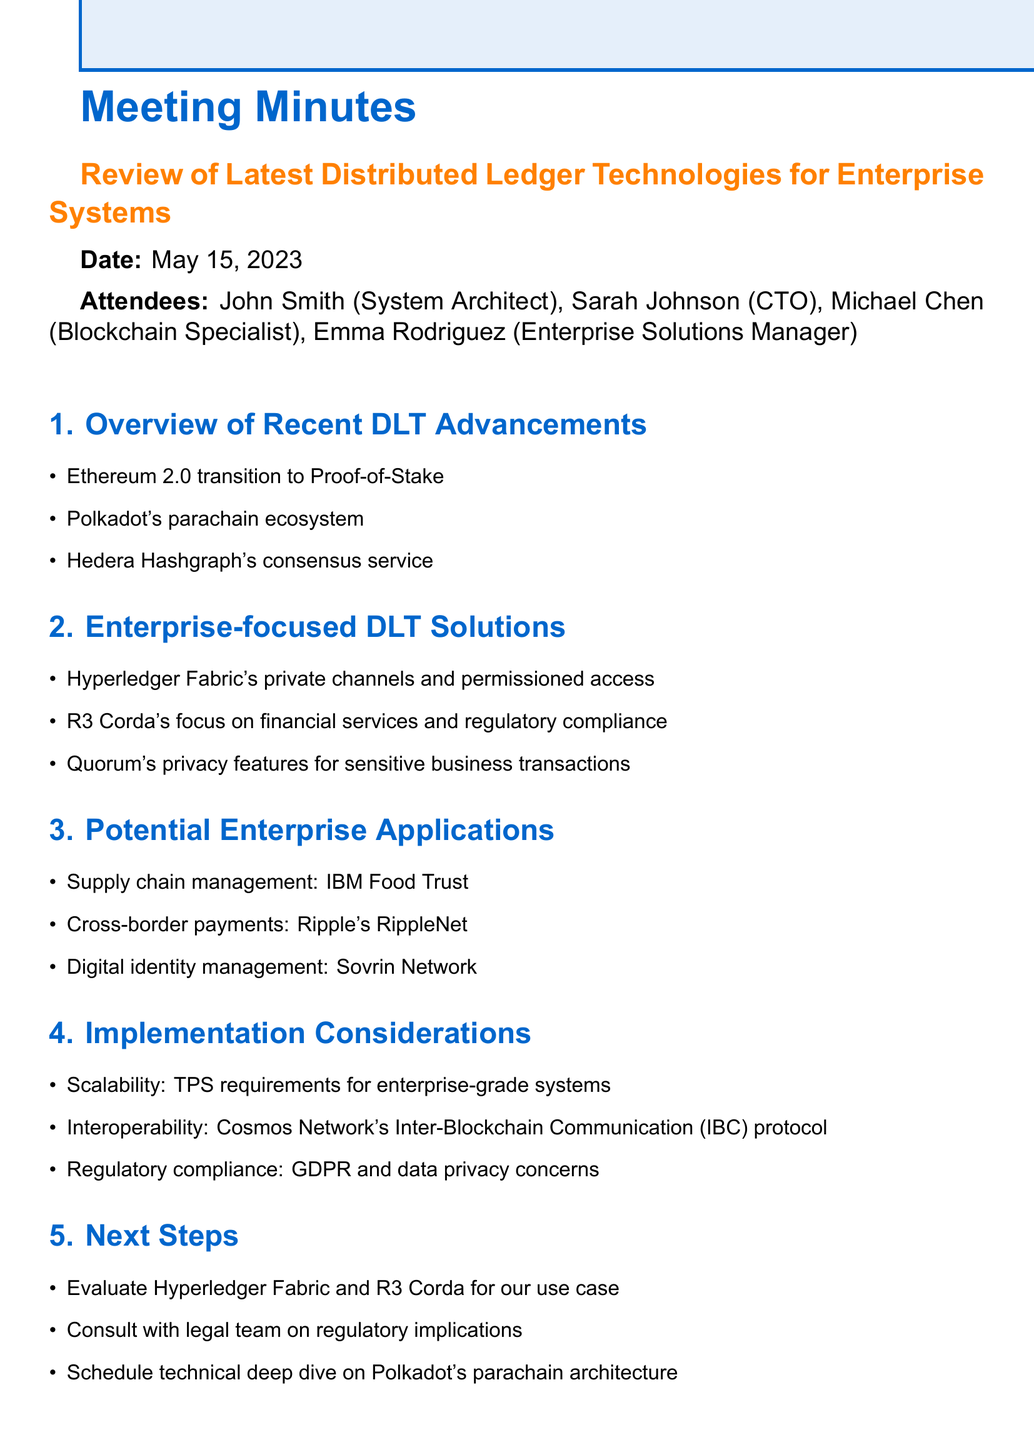What is the date of the meeting? The date is specified at the beginning of the document under the meeting details.
Answer: May 15, 2023 Who is the CTO present at the meeting? The attendees section lists the attendees and their roles, including the CTO.
Answer: Sarah Johnson What is one DLT solution focused on financial services? The Enterprise-focused DLT Solutions section mentions specific solutions, including one aimed at financial services.
Answer: R3 Corda What is one example of a potential application in supply chain management? The document lists potential applications, including one specific to supply chain management.
Answer: IBM Food Trust Which DLT is known for its private channels and permissioned access? The document lists enterprise-focused DLT solutions and identifies key properties of Hyperledger Fabric.
Answer: Hyperledger Fabric What is a key implementation consideration related to data privacy? The Implementation Considerations section highlights several areas, including one that addresses regulatory aspects related to data privacy.
Answer: GDPR 